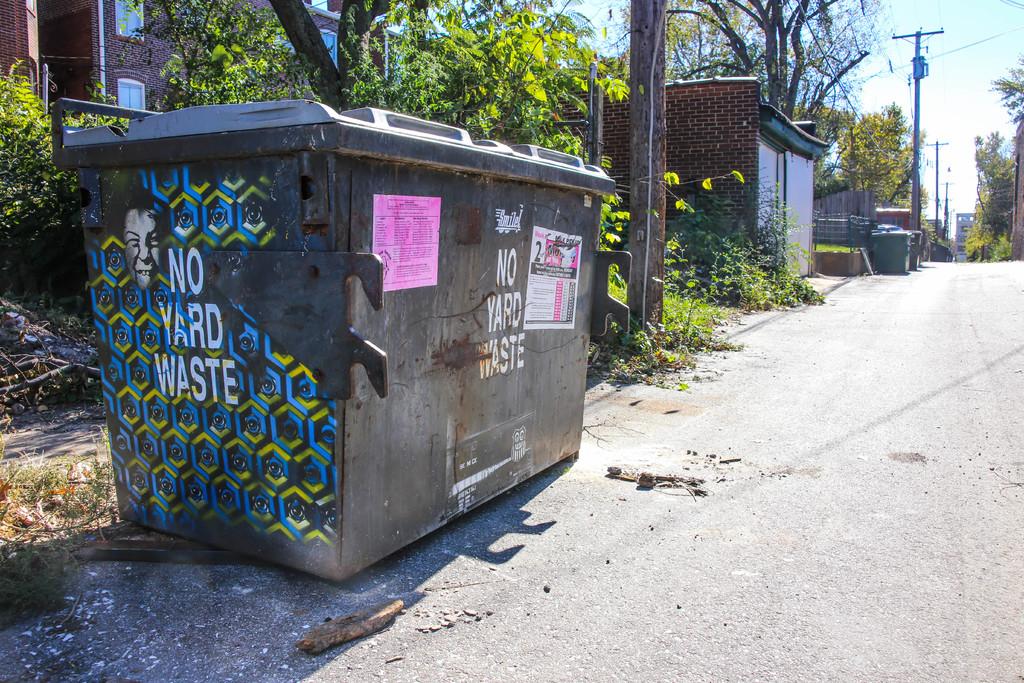What kind of waste are you not supposed to put in the dumpster?
Provide a succinct answer. Yard waste. What does the dumpster have written on its side?
Give a very brief answer. No yard waste. 